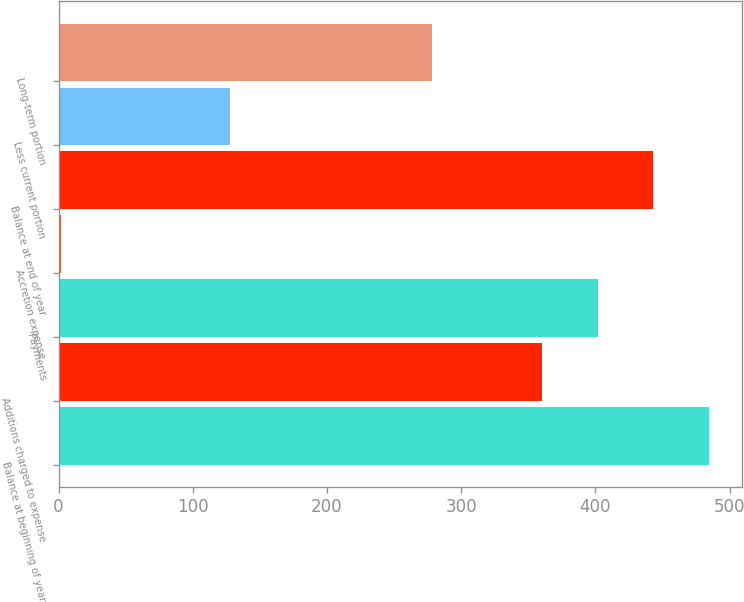Convert chart to OTSL. <chart><loc_0><loc_0><loc_500><loc_500><bar_chart><fcel>Balance at beginning of year<fcel>Additions charged to expense<fcel>Payments<fcel>Accretion expense<fcel>Balance at end of year<fcel>Less current portion<fcel>Long-term portion<nl><fcel>484.81<fcel>360.4<fcel>401.87<fcel>1.9<fcel>443.34<fcel>127.7<fcel>278.1<nl></chart> 